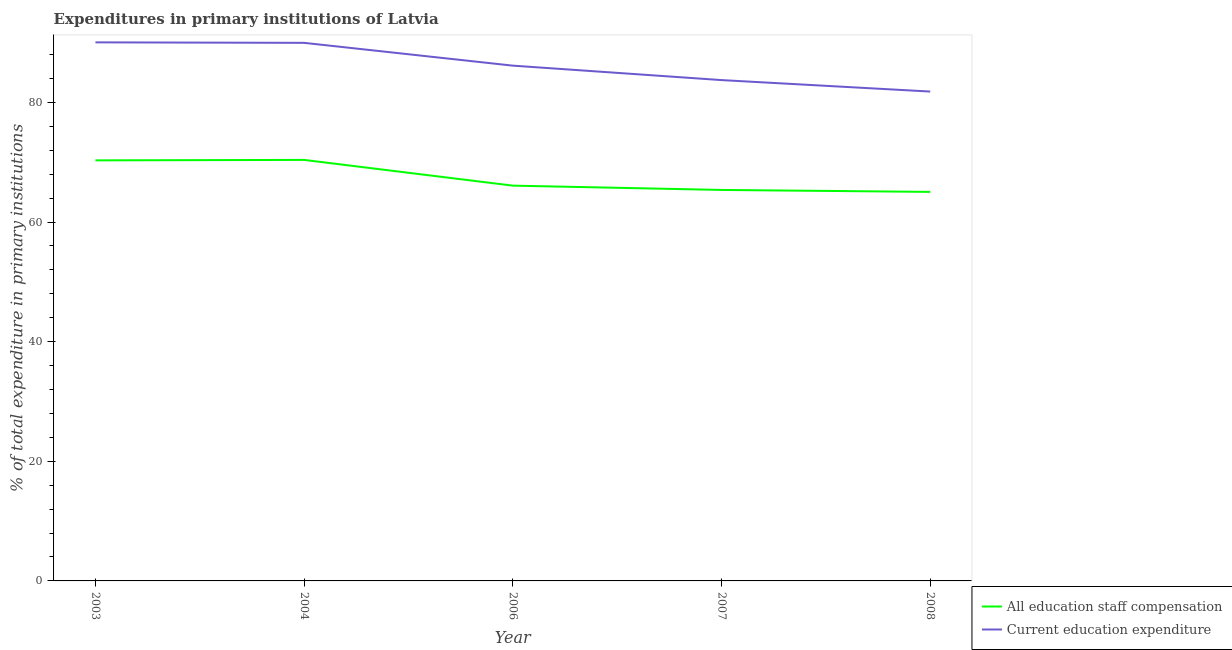Is the number of lines equal to the number of legend labels?
Keep it short and to the point. Yes. What is the expenditure in staff compensation in 2008?
Keep it short and to the point. 65.05. Across all years, what is the maximum expenditure in education?
Offer a very short reply. 90.05. Across all years, what is the minimum expenditure in education?
Offer a terse response. 81.82. In which year was the expenditure in education maximum?
Give a very brief answer. 2003. In which year was the expenditure in education minimum?
Keep it short and to the point. 2008. What is the total expenditure in education in the graph?
Your response must be concise. 431.74. What is the difference between the expenditure in staff compensation in 2006 and that in 2007?
Offer a very short reply. 0.72. What is the difference between the expenditure in staff compensation in 2004 and the expenditure in education in 2008?
Give a very brief answer. -11.43. What is the average expenditure in staff compensation per year?
Provide a short and direct response. 67.45. In the year 2008, what is the difference between the expenditure in education and expenditure in staff compensation?
Your response must be concise. 16.78. In how many years, is the expenditure in education greater than 64 %?
Make the answer very short. 5. What is the ratio of the expenditure in staff compensation in 2007 to that in 2008?
Offer a very short reply. 1.01. What is the difference between the highest and the second highest expenditure in education?
Your response must be concise. 0.08. What is the difference between the highest and the lowest expenditure in education?
Make the answer very short. 8.23. In how many years, is the expenditure in staff compensation greater than the average expenditure in staff compensation taken over all years?
Your response must be concise. 2. Is the sum of the expenditure in education in 2006 and 2008 greater than the maximum expenditure in staff compensation across all years?
Offer a very short reply. Yes. Is the expenditure in education strictly greater than the expenditure in staff compensation over the years?
Offer a terse response. Yes. Does the graph contain any zero values?
Give a very brief answer. No. How many legend labels are there?
Your answer should be very brief. 2. How are the legend labels stacked?
Give a very brief answer. Vertical. What is the title of the graph?
Offer a very short reply. Expenditures in primary institutions of Latvia. What is the label or title of the Y-axis?
Offer a very short reply. % of total expenditure in primary institutions. What is the % of total expenditure in primary institutions of All education staff compensation in 2003?
Offer a very short reply. 70.32. What is the % of total expenditure in primary institutions in Current education expenditure in 2003?
Offer a very short reply. 90.05. What is the % of total expenditure in primary institutions in All education staff compensation in 2004?
Offer a very short reply. 70.39. What is the % of total expenditure in primary institutions of Current education expenditure in 2004?
Make the answer very short. 89.97. What is the % of total expenditure in primary institutions in All education staff compensation in 2006?
Keep it short and to the point. 66.09. What is the % of total expenditure in primary institutions in Current education expenditure in 2006?
Offer a very short reply. 86.16. What is the % of total expenditure in primary institutions of All education staff compensation in 2007?
Give a very brief answer. 65.37. What is the % of total expenditure in primary institutions of Current education expenditure in 2007?
Provide a succinct answer. 83.74. What is the % of total expenditure in primary institutions of All education staff compensation in 2008?
Give a very brief answer. 65.05. What is the % of total expenditure in primary institutions in Current education expenditure in 2008?
Your response must be concise. 81.82. Across all years, what is the maximum % of total expenditure in primary institutions in All education staff compensation?
Offer a terse response. 70.39. Across all years, what is the maximum % of total expenditure in primary institutions in Current education expenditure?
Give a very brief answer. 90.05. Across all years, what is the minimum % of total expenditure in primary institutions in All education staff compensation?
Your answer should be very brief. 65.05. Across all years, what is the minimum % of total expenditure in primary institutions in Current education expenditure?
Your answer should be compact. 81.82. What is the total % of total expenditure in primary institutions in All education staff compensation in the graph?
Keep it short and to the point. 337.23. What is the total % of total expenditure in primary institutions of Current education expenditure in the graph?
Provide a short and direct response. 431.74. What is the difference between the % of total expenditure in primary institutions in All education staff compensation in 2003 and that in 2004?
Give a very brief answer. -0.07. What is the difference between the % of total expenditure in primary institutions of Current education expenditure in 2003 and that in 2004?
Your answer should be compact. 0.08. What is the difference between the % of total expenditure in primary institutions of All education staff compensation in 2003 and that in 2006?
Offer a very short reply. 4.23. What is the difference between the % of total expenditure in primary institutions in Current education expenditure in 2003 and that in 2006?
Offer a very short reply. 3.89. What is the difference between the % of total expenditure in primary institutions of All education staff compensation in 2003 and that in 2007?
Your response must be concise. 4.95. What is the difference between the % of total expenditure in primary institutions in Current education expenditure in 2003 and that in 2007?
Keep it short and to the point. 6.31. What is the difference between the % of total expenditure in primary institutions of All education staff compensation in 2003 and that in 2008?
Provide a succinct answer. 5.27. What is the difference between the % of total expenditure in primary institutions of Current education expenditure in 2003 and that in 2008?
Your answer should be very brief. 8.23. What is the difference between the % of total expenditure in primary institutions of All education staff compensation in 2004 and that in 2006?
Keep it short and to the point. 4.3. What is the difference between the % of total expenditure in primary institutions of Current education expenditure in 2004 and that in 2006?
Your answer should be compact. 3.81. What is the difference between the % of total expenditure in primary institutions in All education staff compensation in 2004 and that in 2007?
Offer a terse response. 5.02. What is the difference between the % of total expenditure in primary institutions of Current education expenditure in 2004 and that in 2007?
Provide a short and direct response. 6.23. What is the difference between the % of total expenditure in primary institutions in All education staff compensation in 2004 and that in 2008?
Provide a succinct answer. 5.35. What is the difference between the % of total expenditure in primary institutions in Current education expenditure in 2004 and that in 2008?
Your answer should be compact. 8.14. What is the difference between the % of total expenditure in primary institutions of All education staff compensation in 2006 and that in 2007?
Provide a short and direct response. 0.72. What is the difference between the % of total expenditure in primary institutions in Current education expenditure in 2006 and that in 2007?
Your answer should be compact. 2.42. What is the difference between the % of total expenditure in primary institutions in All education staff compensation in 2006 and that in 2008?
Your answer should be very brief. 1.05. What is the difference between the % of total expenditure in primary institutions in Current education expenditure in 2006 and that in 2008?
Make the answer very short. 4.33. What is the difference between the % of total expenditure in primary institutions in All education staff compensation in 2007 and that in 2008?
Your answer should be compact. 0.33. What is the difference between the % of total expenditure in primary institutions of Current education expenditure in 2007 and that in 2008?
Provide a succinct answer. 1.92. What is the difference between the % of total expenditure in primary institutions in All education staff compensation in 2003 and the % of total expenditure in primary institutions in Current education expenditure in 2004?
Provide a succinct answer. -19.65. What is the difference between the % of total expenditure in primary institutions in All education staff compensation in 2003 and the % of total expenditure in primary institutions in Current education expenditure in 2006?
Offer a terse response. -15.84. What is the difference between the % of total expenditure in primary institutions of All education staff compensation in 2003 and the % of total expenditure in primary institutions of Current education expenditure in 2007?
Ensure brevity in your answer.  -13.42. What is the difference between the % of total expenditure in primary institutions in All education staff compensation in 2003 and the % of total expenditure in primary institutions in Current education expenditure in 2008?
Offer a terse response. -11.5. What is the difference between the % of total expenditure in primary institutions in All education staff compensation in 2004 and the % of total expenditure in primary institutions in Current education expenditure in 2006?
Your answer should be compact. -15.76. What is the difference between the % of total expenditure in primary institutions of All education staff compensation in 2004 and the % of total expenditure in primary institutions of Current education expenditure in 2007?
Give a very brief answer. -13.35. What is the difference between the % of total expenditure in primary institutions of All education staff compensation in 2004 and the % of total expenditure in primary institutions of Current education expenditure in 2008?
Offer a very short reply. -11.43. What is the difference between the % of total expenditure in primary institutions of All education staff compensation in 2006 and the % of total expenditure in primary institutions of Current education expenditure in 2007?
Provide a succinct answer. -17.65. What is the difference between the % of total expenditure in primary institutions in All education staff compensation in 2006 and the % of total expenditure in primary institutions in Current education expenditure in 2008?
Your answer should be very brief. -15.73. What is the difference between the % of total expenditure in primary institutions of All education staff compensation in 2007 and the % of total expenditure in primary institutions of Current education expenditure in 2008?
Your response must be concise. -16.45. What is the average % of total expenditure in primary institutions in All education staff compensation per year?
Provide a short and direct response. 67.45. What is the average % of total expenditure in primary institutions of Current education expenditure per year?
Provide a succinct answer. 86.35. In the year 2003, what is the difference between the % of total expenditure in primary institutions in All education staff compensation and % of total expenditure in primary institutions in Current education expenditure?
Give a very brief answer. -19.73. In the year 2004, what is the difference between the % of total expenditure in primary institutions of All education staff compensation and % of total expenditure in primary institutions of Current education expenditure?
Give a very brief answer. -19.57. In the year 2006, what is the difference between the % of total expenditure in primary institutions of All education staff compensation and % of total expenditure in primary institutions of Current education expenditure?
Your answer should be very brief. -20.06. In the year 2007, what is the difference between the % of total expenditure in primary institutions in All education staff compensation and % of total expenditure in primary institutions in Current education expenditure?
Keep it short and to the point. -18.37. In the year 2008, what is the difference between the % of total expenditure in primary institutions of All education staff compensation and % of total expenditure in primary institutions of Current education expenditure?
Make the answer very short. -16.78. What is the ratio of the % of total expenditure in primary institutions of All education staff compensation in 2003 to that in 2004?
Make the answer very short. 1. What is the ratio of the % of total expenditure in primary institutions in Current education expenditure in 2003 to that in 2004?
Offer a terse response. 1. What is the ratio of the % of total expenditure in primary institutions in All education staff compensation in 2003 to that in 2006?
Your answer should be compact. 1.06. What is the ratio of the % of total expenditure in primary institutions in Current education expenditure in 2003 to that in 2006?
Offer a terse response. 1.05. What is the ratio of the % of total expenditure in primary institutions of All education staff compensation in 2003 to that in 2007?
Offer a terse response. 1.08. What is the ratio of the % of total expenditure in primary institutions of Current education expenditure in 2003 to that in 2007?
Keep it short and to the point. 1.08. What is the ratio of the % of total expenditure in primary institutions of All education staff compensation in 2003 to that in 2008?
Offer a terse response. 1.08. What is the ratio of the % of total expenditure in primary institutions in Current education expenditure in 2003 to that in 2008?
Ensure brevity in your answer.  1.1. What is the ratio of the % of total expenditure in primary institutions of All education staff compensation in 2004 to that in 2006?
Offer a terse response. 1.07. What is the ratio of the % of total expenditure in primary institutions in Current education expenditure in 2004 to that in 2006?
Provide a short and direct response. 1.04. What is the ratio of the % of total expenditure in primary institutions of All education staff compensation in 2004 to that in 2007?
Give a very brief answer. 1.08. What is the ratio of the % of total expenditure in primary institutions of Current education expenditure in 2004 to that in 2007?
Your answer should be compact. 1.07. What is the ratio of the % of total expenditure in primary institutions of All education staff compensation in 2004 to that in 2008?
Your answer should be compact. 1.08. What is the ratio of the % of total expenditure in primary institutions of Current education expenditure in 2004 to that in 2008?
Give a very brief answer. 1.1. What is the ratio of the % of total expenditure in primary institutions of Current education expenditure in 2006 to that in 2007?
Offer a very short reply. 1.03. What is the ratio of the % of total expenditure in primary institutions in All education staff compensation in 2006 to that in 2008?
Give a very brief answer. 1.02. What is the ratio of the % of total expenditure in primary institutions of Current education expenditure in 2006 to that in 2008?
Keep it short and to the point. 1.05. What is the ratio of the % of total expenditure in primary institutions in Current education expenditure in 2007 to that in 2008?
Provide a short and direct response. 1.02. What is the difference between the highest and the second highest % of total expenditure in primary institutions in All education staff compensation?
Make the answer very short. 0.07. What is the difference between the highest and the second highest % of total expenditure in primary institutions of Current education expenditure?
Provide a short and direct response. 0.08. What is the difference between the highest and the lowest % of total expenditure in primary institutions in All education staff compensation?
Make the answer very short. 5.35. What is the difference between the highest and the lowest % of total expenditure in primary institutions of Current education expenditure?
Provide a short and direct response. 8.23. 